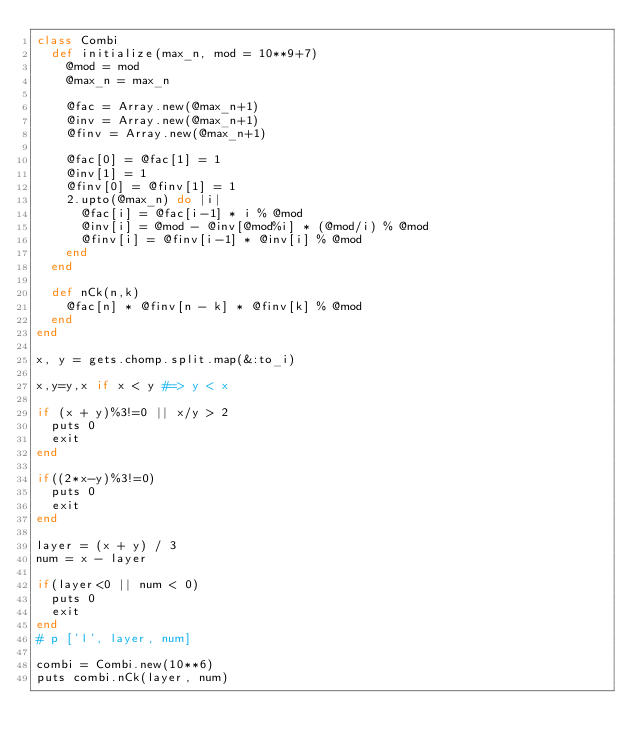<code> <loc_0><loc_0><loc_500><loc_500><_Ruby_>class Combi
  def initialize(max_n, mod = 10**9+7)
    @mod = mod
    @max_n = max_n
 
    @fac = Array.new(@max_n+1)
    @inv = Array.new(@max_n+1)
    @finv = Array.new(@max_n+1)
 
    @fac[0] = @fac[1] = 1
    @inv[1] = 1
    @finv[0] = @finv[1] = 1
    2.upto(@max_n) do |i|
      @fac[i] = @fac[i-1] * i % @mod
      @inv[i] = @mod - @inv[@mod%i] * (@mod/i) % @mod
      @finv[i] = @finv[i-1] * @inv[i] % @mod
    end
  end
 
  def nCk(n,k)
    @fac[n] * @finv[n - k] * @finv[k] % @mod
  end
end
 
x, y = gets.chomp.split.map(&:to_i)
 
x,y=y,x if x < y #=> y < x
 
if (x + y)%3!=0 || x/y > 2
  puts 0
  exit
end

if((2*x-y)%3!=0)
  puts 0
  exit
end
 
layer = (x + y) / 3
num = x - layer
 
if(layer<0 || num < 0)
  puts 0
  exit
end
# p ['l', layer, num]
 
combi = Combi.new(10**6)
puts combi.nCk(layer, num)</code> 